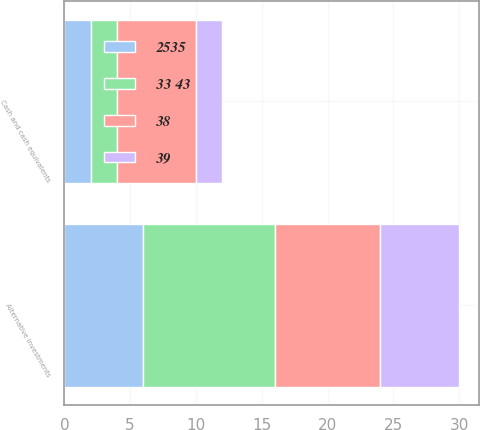Convert chart to OTSL. <chart><loc_0><loc_0><loc_500><loc_500><stacked_bar_chart><ecel><fcel>Cash and cash equivalents<fcel>Alternative investments<nl><fcel>33 43<fcel>2<fcel>10<nl><fcel>38<fcel>6<fcel>8<nl><fcel>2535<fcel>2<fcel>6<nl><fcel>39<fcel>2<fcel>6<nl></chart> 